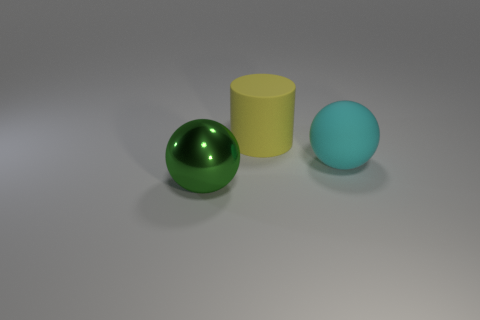Is there any other thing that has the same material as the big green ball?
Give a very brief answer. No. There is a sphere right of the yellow cylinder; is its size the same as the big yellow rubber cylinder?
Provide a short and direct response. Yes. Do the big object behind the large cyan object and the sphere that is right of the yellow cylinder have the same material?
Make the answer very short. Yes. Is there another yellow thing of the same size as the shiny object?
Give a very brief answer. Yes. There is a large rubber thing in front of the matte thing that is behind the ball that is behind the green metallic thing; what shape is it?
Give a very brief answer. Sphere. Is the number of matte balls left of the green shiny ball greater than the number of large yellow objects?
Offer a terse response. No. Are there any cyan things of the same shape as the yellow rubber object?
Ensure brevity in your answer.  No. Do the cylinder and the sphere that is in front of the rubber ball have the same material?
Ensure brevity in your answer.  No. What color is the big cylinder?
Your answer should be very brief. Yellow. What number of metal objects are in front of the object that is behind the large ball that is to the right of the shiny thing?
Offer a terse response. 1. 